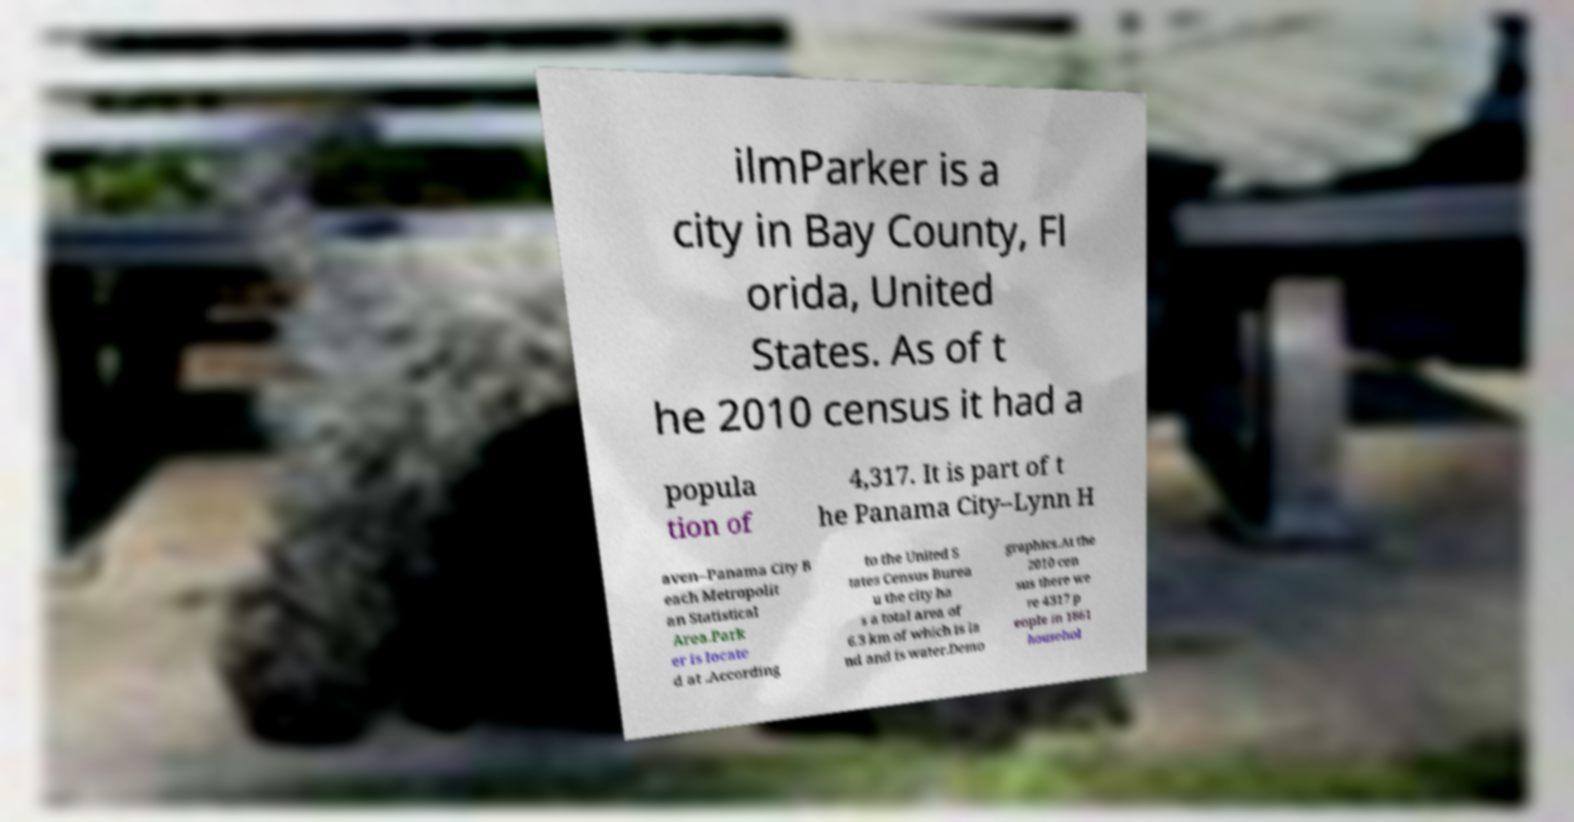For documentation purposes, I need the text within this image transcribed. Could you provide that? ilmParker is a city in Bay County, Fl orida, United States. As of t he 2010 census it had a popula tion of 4,317. It is part of t he Panama City–Lynn H aven–Panama City B each Metropolit an Statistical Area.Park er is locate d at .According to the United S tates Census Burea u the city ha s a total area of 6.3 km of which is la nd and is water.Demo graphics.At the 2010 cen sus there we re 4317 p eople in 1861 househol 